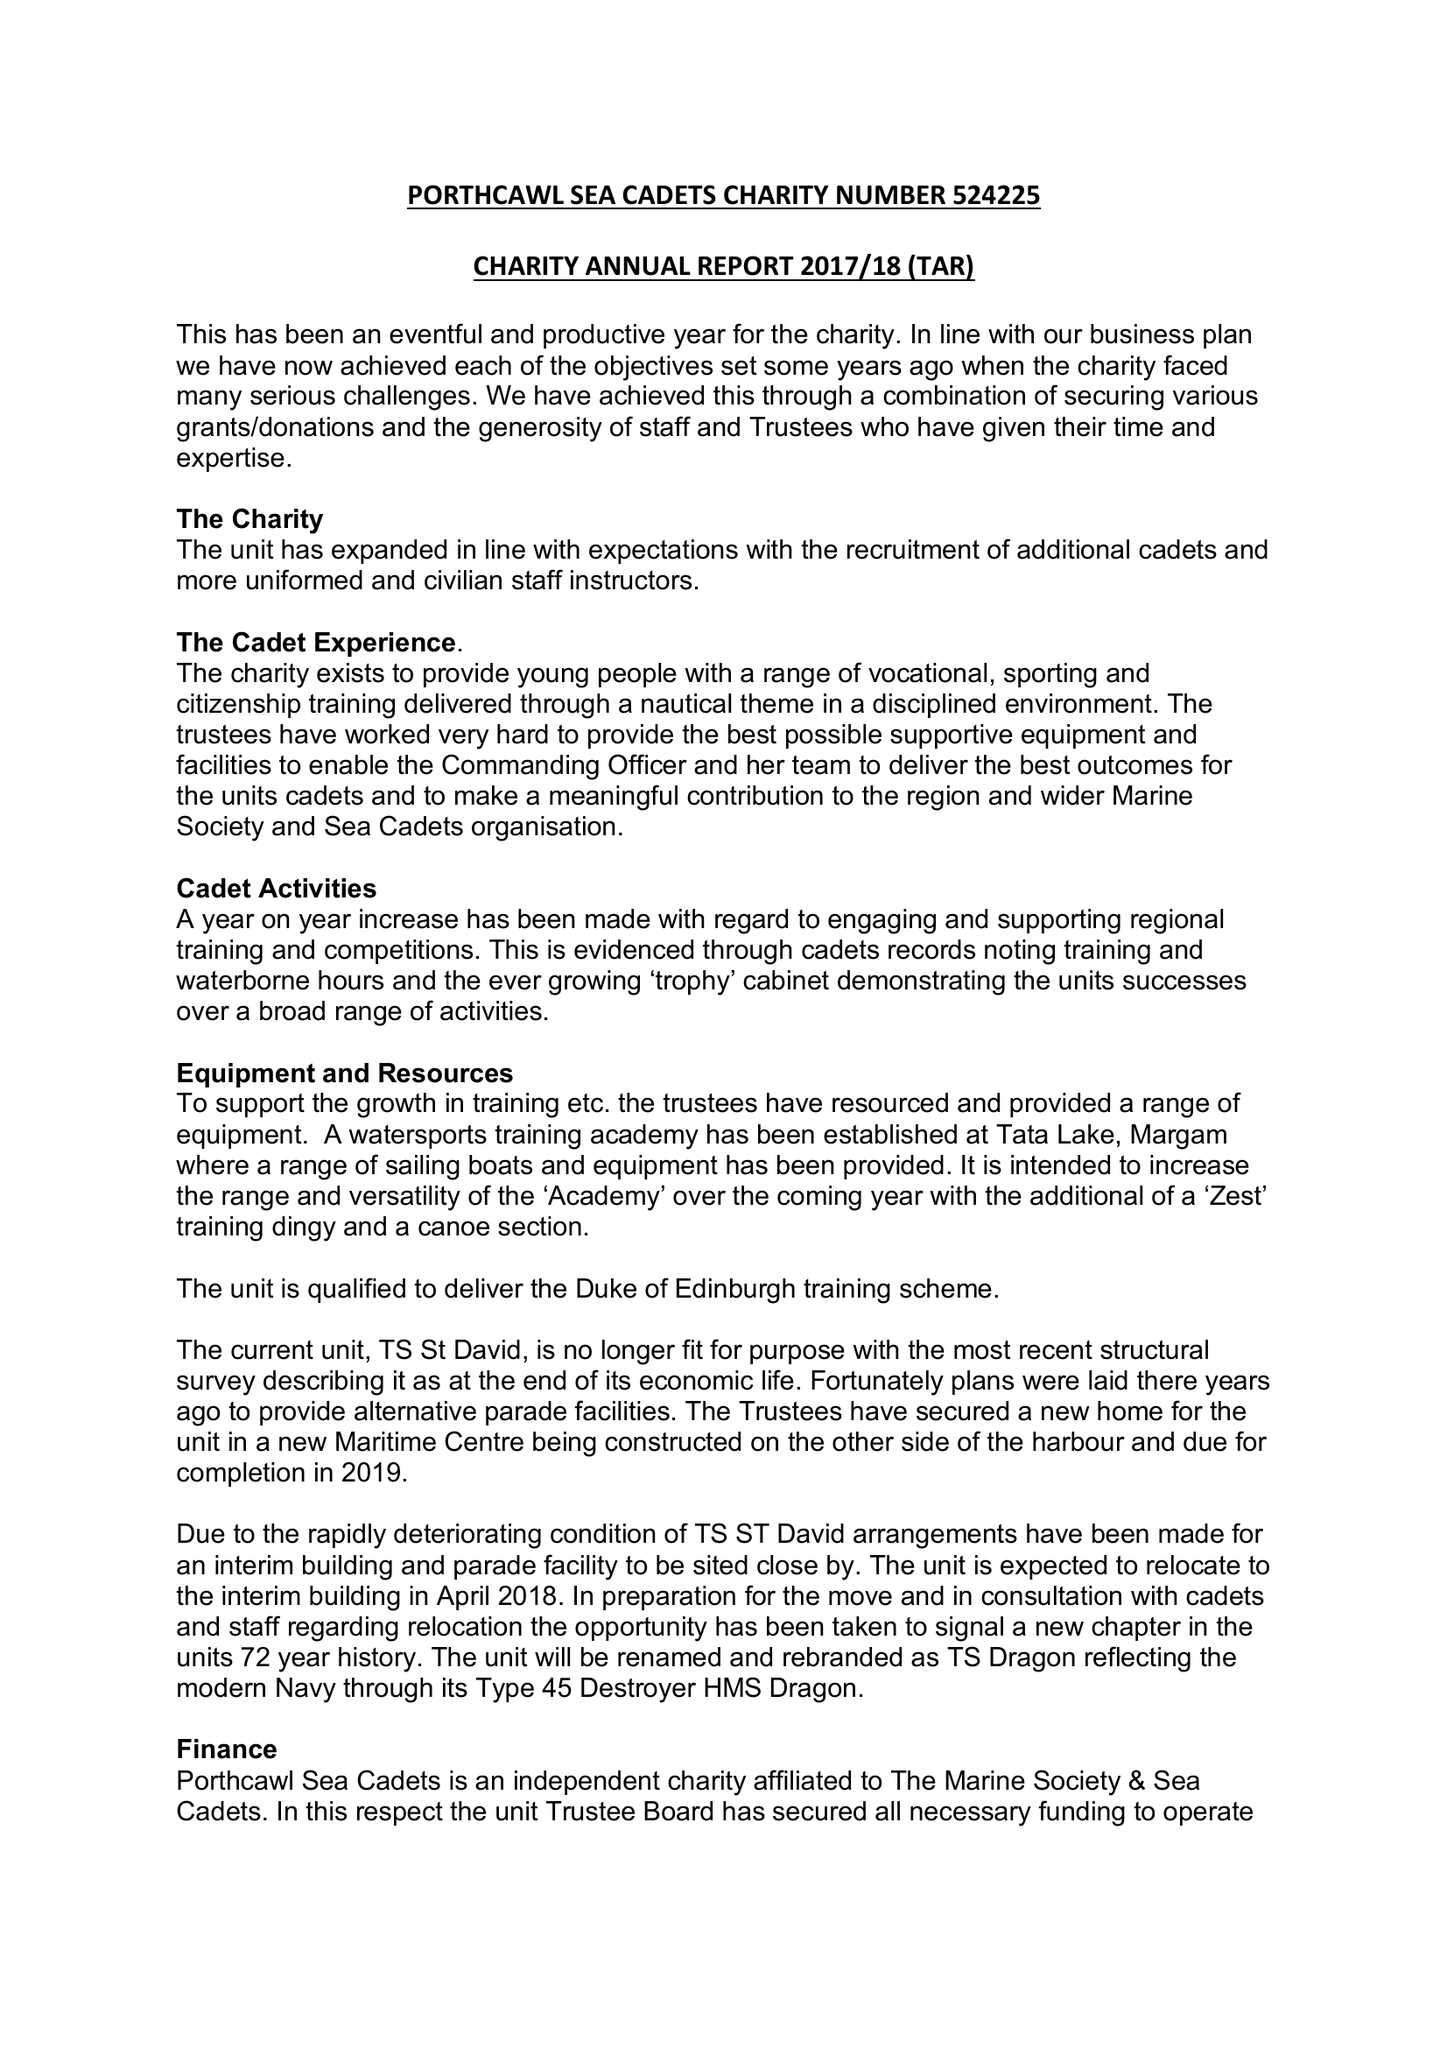What is the value for the address__street_line?
Answer the question using a single word or phrase. 16 KITTIWAKE CLOSE 